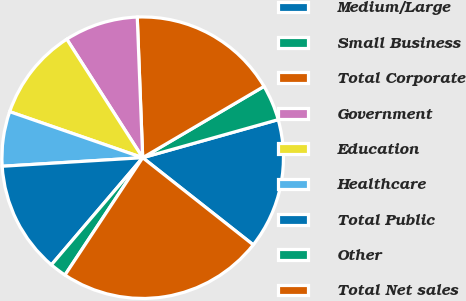Convert chart. <chart><loc_0><loc_0><loc_500><loc_500><pie_chart><fcel>Medium/Large<fcel>Small Business<fcel>Total Corporate<fcel>Government<fcel>Education<fcel>Healthcare<fcel>Total Public<fcel>Other<fcel>Total Net sales<nl><fcel>14.98%<fcel>4.1%<fcel>17.16%<fcel>8.45%<fcel>10.63%<fcel>6.27%<fcel>12.8%<fcel>1.92%<fcel>23.69%<nl></chart> 